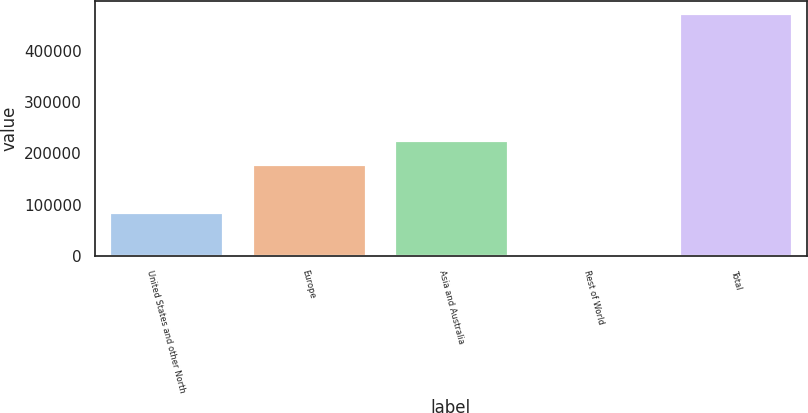<chart> <loc_0><loc_0><loc_500><loc_500><bar_chart><fcel>United States and other North<fcel>Europe<fcel>Asia and Australia<fcel>Rest of World<fcel>Total<nl><fcel>86181<fcel>179584<fcel>226636<fcel>3959<fcel>474482<nl></chart> 